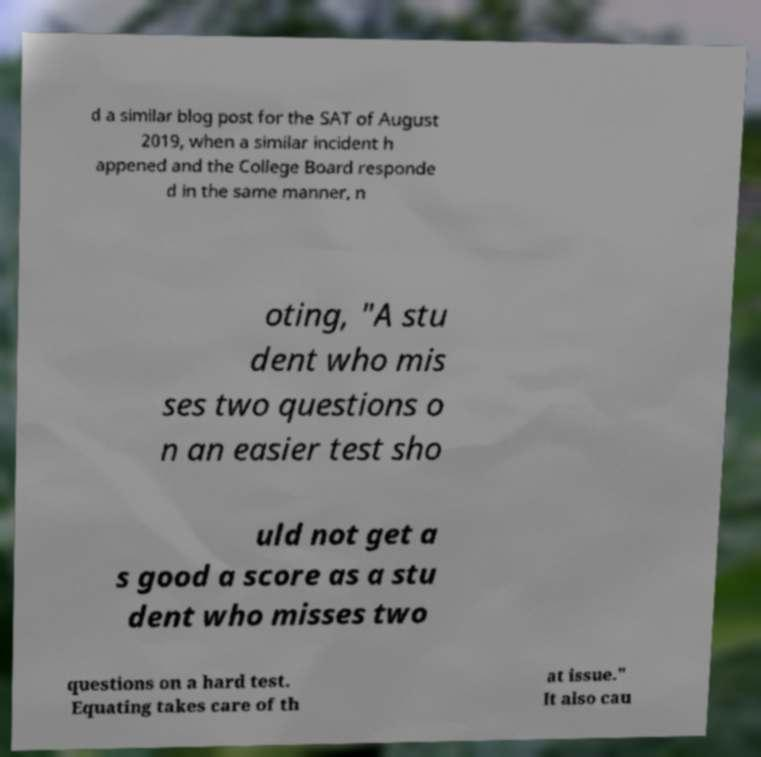I need the written content from this picture converted into text. Can you do that? d a similar blog post for the SAT of August 2019, when a similar incident h appened and the College Board responde d in the same manner, n oting, "A stu dent who mis ses two questions o n an easier test sho uld not get a s good a score as a stu dent who misses two questions on a hard test. Equating takes care of th at issue." It also cau 